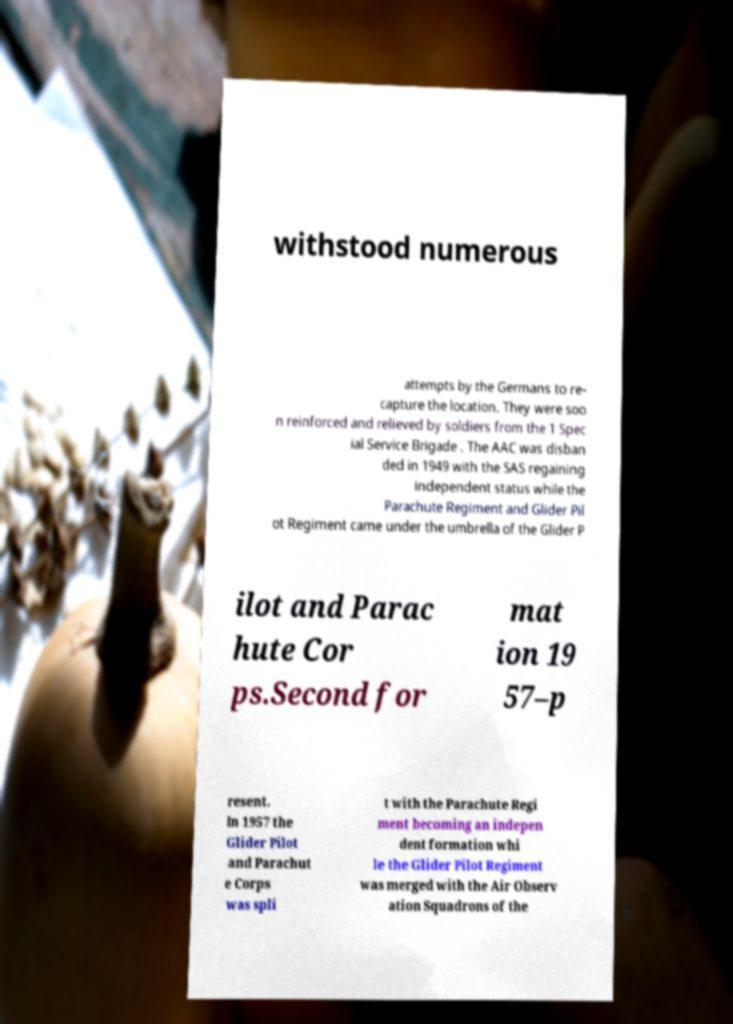Can you accurately transcribe the text from the provided image for me? withstood numerous attempts by the Germans to re- capture the location. They were soo n reinforced and relieved by soldiers from the 1 Spec ial Service Brigade . The AAC was disban ded in 1949 with the SAS regaining independent status while the Parachute Regiment and Glider Pil ot Regiment came under the umbrella of the Glider P ilot and Parac hute Cor ps.Second for mat ion 19 57–p resent. In 1957 the Glider Pilot and Parachut e Corps was spli t with the Parachute Regi ment becoming an indepen dent formation whi le the Glider Pilot Regiment was merged with the Air Observ ation Squadrons of the 